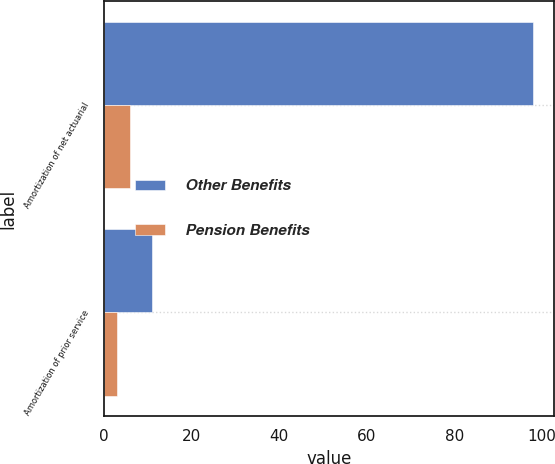<chart> <loc_0><loc_0><loc_500><loc_500><stacked_bar_chart><ecel><fcel>Amortization of net actuarial<fcel>Amortization of prior service<nl><fcel>Other Benefits<fcel>98<fcel>11<nl><fcel>Pension Benefits<fcel>6<fcel>3<nl></chart> 